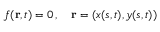<formula> <loc_0><loc_0><loc_500><loc_500>f ( r , t ) = 0 \, , \quad r = ( x ( s , t ) , y ( s , t ) )</formula> 